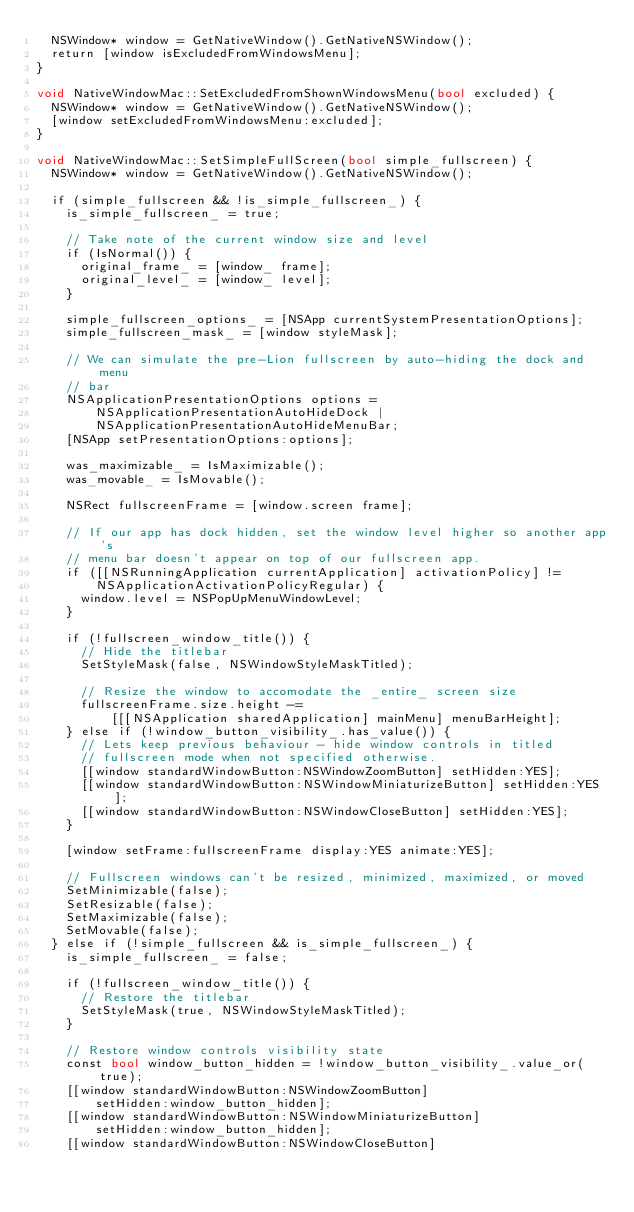Convert code to text. <code><loc_0><loc_0><loc_500><loc_500><_ObjectiveC_>  NSWindow* window = GetNativeWindow().GetNativeNSWindow();
  return [window isExcludedFromWindowsMenu];
}

void NativeWindowMac::SetExcludedFromShownWindowsMenu(bool excluded) {
  NSWindow* window = GetNativeWindow().GetNativeNSWindow();
  [window setExcludedFromWindowsMenu:excluded];
}

void NativeWindowMac::SetSimpleFullScreen(bool simple_fullscreen) {
  NSWindow* window = GetNativeWindow().GetNativeNSWindow();

  if (simple_fullscreen && !is_simple_fullscreen_) {
    is_simple_fullscreen_ = true;

    // Take note of the current window size and level
    if (IsNormal()) {
      original_frame_ = [window_ frame];
      original_level_ = [window_ level];
    }

    simple_fullscreen_options_ = [NSApp currentSystemPresentationOptions];
    simple_fullscreen_mask_ = [window styleMask];

    // We can simulate the pre-Lion fullscreen by auto-hiding the dock and menu
    // bar
    NSApplicationPresentationOptions options =
        NSApplicationPresentationAutoHideDock |
        NSApplicationPresentationAutoHideMenuBar;
    [NSApp setPresentationOptions:options];

    was_maximizable_ = IsMaximizable();
    was_movable_ = IsMovable();

    NSRect fullscreenFrame = [window.screen frame];

    // If our app has dock hidden, set the window level higher so another app's
    // menu bar doesn't appear on top of our fullscreen app.
    if ([[NSRunningApplication currentApplication] activationPolicy] !=
        NSApplicationActivationPolicyRegular) {
      window.level = NSPopUpMenuWindowLevel;
    }

    if (!fullscreen_window_title()) {
      // Hide the titlebar
      SetStyleMask(false, NSWindowStyleMaskTitled);

      // Resize the window to accomodate the _entire_ screen size
      fullscreenFrame.size.height -=
          [[[NSApplication sharedApplication] mainMenu] menuBarHeight];
    } else if (!window_button_visibility_.has_value()) {
      // Lets keep previous behaviour - hide window controls in titled
      // fullscreen mode when not specified otherwise.
      [[window standardWindowButton:NSWindowZoomButton] setHidden:YES];
      [[window standardWindowButton:NSWindowMiniaturizeButton] setHidden:YES];
      [[window standardWindowButton:NSWindowCloseButton] setHidden:YES];
    }

    [window setFrame:fullscreenFrame display:YES animate:YES];

    // Fullscreen windows can't be resized, minimized, maximized, or moved
    SetMinimizable(false);
    SetResizable(false);
    SetMaximizable(false);
    SetMovable(false);
  } else if (!simple_fullscreen && is_simple_fullscreen_) {
    is_simple_fullscreen_ = false;

    if (!fullscreen_window_title()) {
      // Restore the titlebar
      SetStyleMask(true, NSWindowStyleMaskTitled);
    }

    // Restore window controls visibility state
    const bool window_button_hidden = !window_button_visibility_.value_or(true);
    [[window standardWindowButton:NSWindowZoomButton]
        setHidden:window_button_hidden];
    [[window standardWindowButton:NSWindowMiniaturizeButton]
        setHidden:window_button_hidden];
    [[window standardWindowButton:NSWindowCloseButton]</code> 